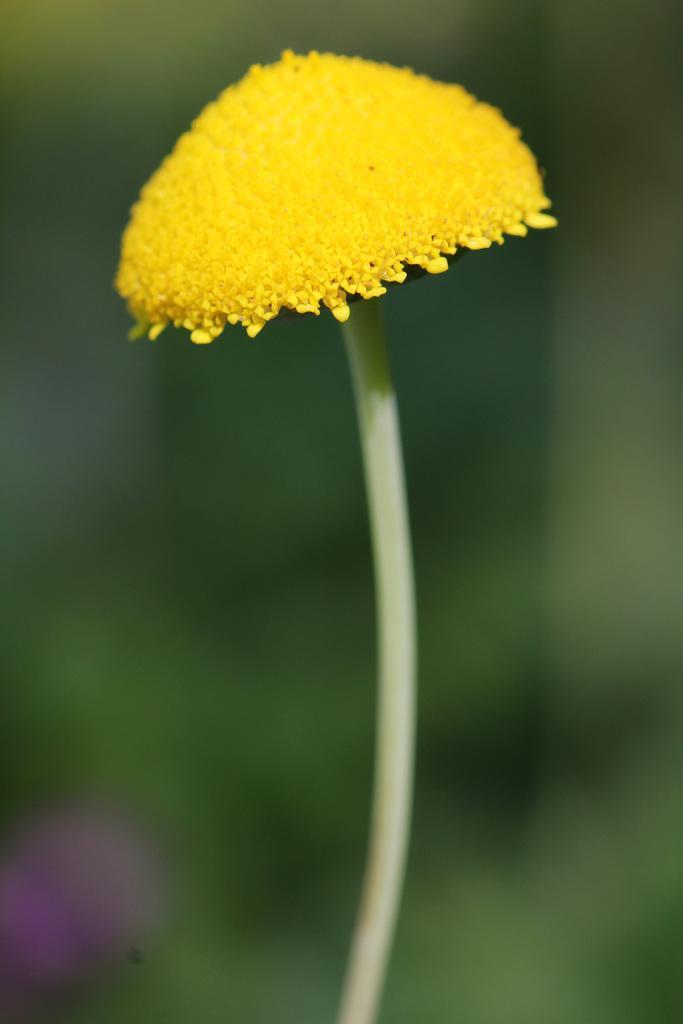In one or two sentences, can you explain what this image depicts? The picture consists of a yellow color flower. The background is blurred. 